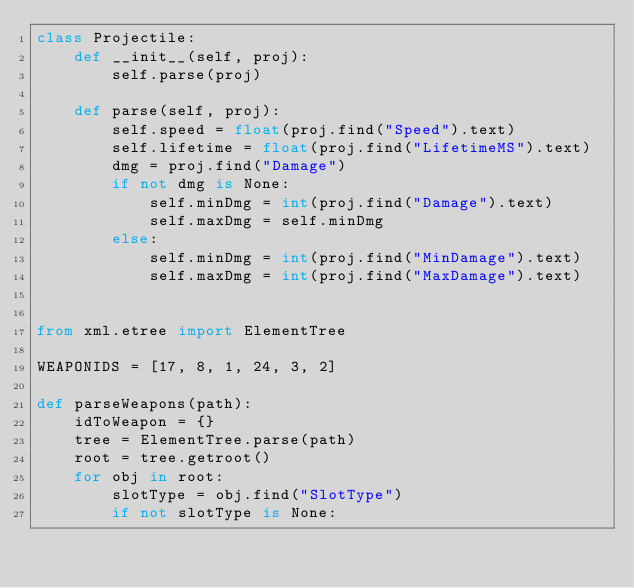<code> <loc_0><loc_0><loc_500><loc_500><_Python_>class Projectile:
    def __init__(self, proj):
        self.parse(proj)

    def parse(self, proj):
        self.speed = float(proj.find("Speed").text)
        self.lifetime = float(proj.find("LifetimeMS").text)
        dmg = proj.find("Damage")
        if not dmg is None:
            self.minDmg = int(proj.find("Damage").text)
            self.maxDmg = self.minDmg
        else:
            self.minDmg = int(proj.find("MinDamage").text)
            self.maxDmg = int(proj.find("MaxDamage").text)


from xml.etree import ElementTree

WEAPONIDS = [17, 8, 1, 24, 3, 2]

def parseWeapons(path):
    idToWeapon = {}
    tree = ElementTree.parse(path)
    root = tree.getroot()
    for obj in root:
        slotType = obj.find("SlotType")
        if not slotType is None:</code> 